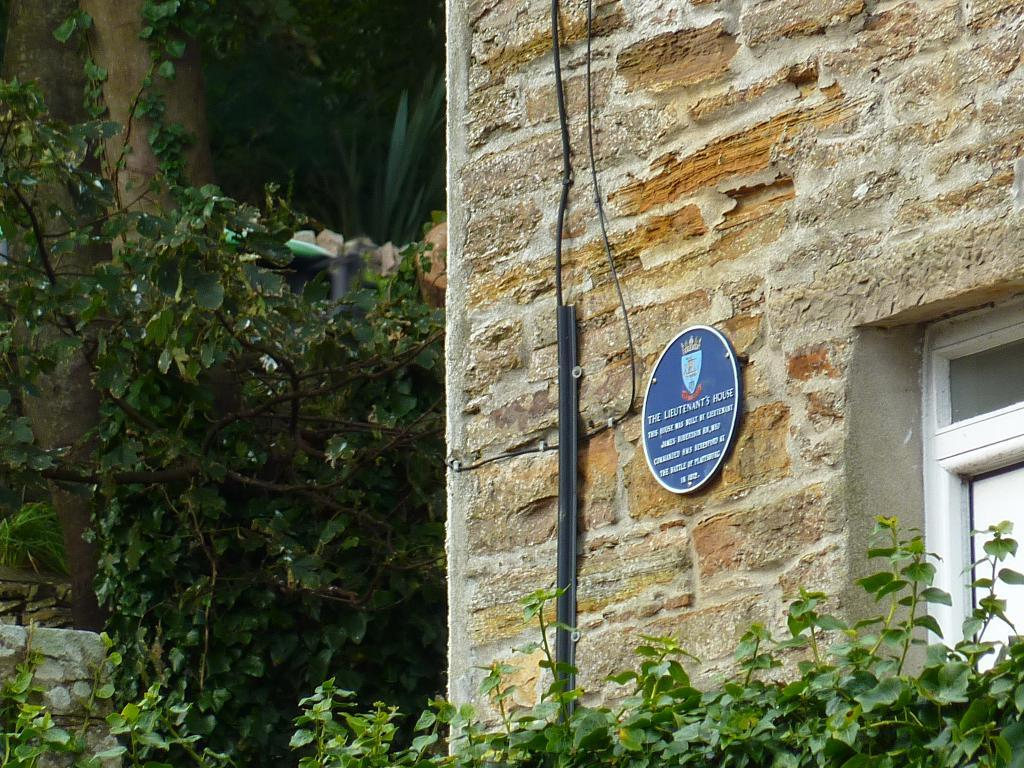What is the main structure in the image? There is a building in the image. What can be seen attached to the building? There are objects attached to the wall of the building. What is located on the left side of the image? There is a tree and plants on the left side of the image. What type of yam is being served in the image? There is no yam present in the image. Can you tell me how many bottles of wine are visible in the image? There is no wine present in the image. 